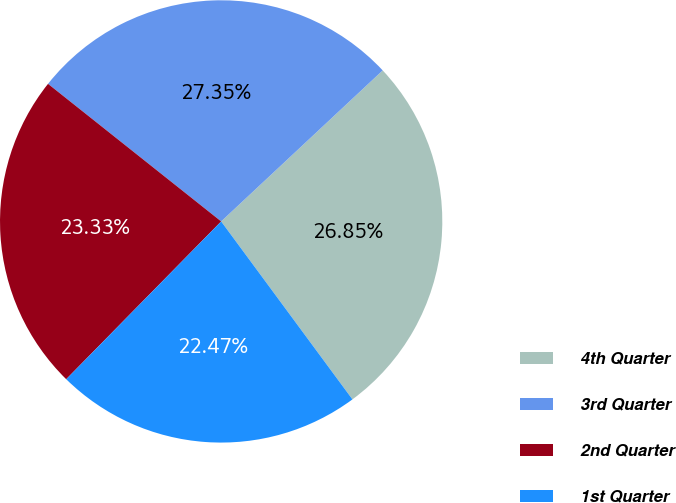Convert chart. <chart><loc_0><loc_0><loc_500><loc_500><pie_chart><fcel>4th Quarter<fcel>3rd Quarter<fcel>2nd Quarter<fcel>1st Quarter<nl><fcel>26.85%<fcel>27.35%<fcel>23.33%<fcel>22.47%<nl></chart> 